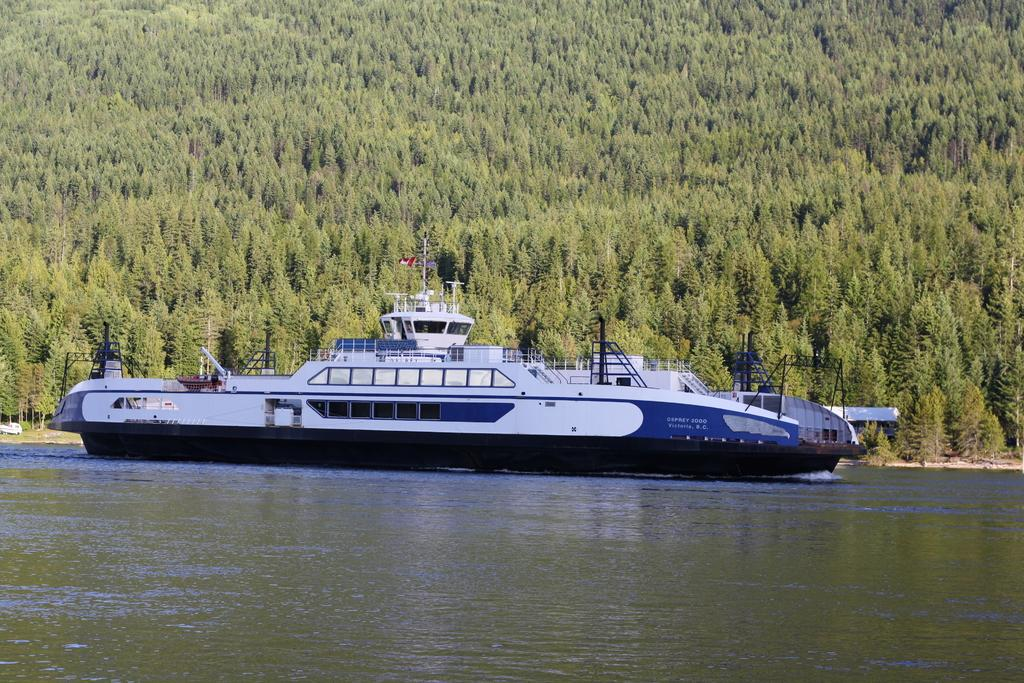What is the main subject of the image? The main subject of the image is a boat. Where is the boat located? The boat is in the middle of a lake. What can be seen in the background of the image? There are trees visible in the image. What type of button can be seen on the zebra in the image? There is no zebra or button present in the image; it features a boat in the middle of a lake with trees in the background. 